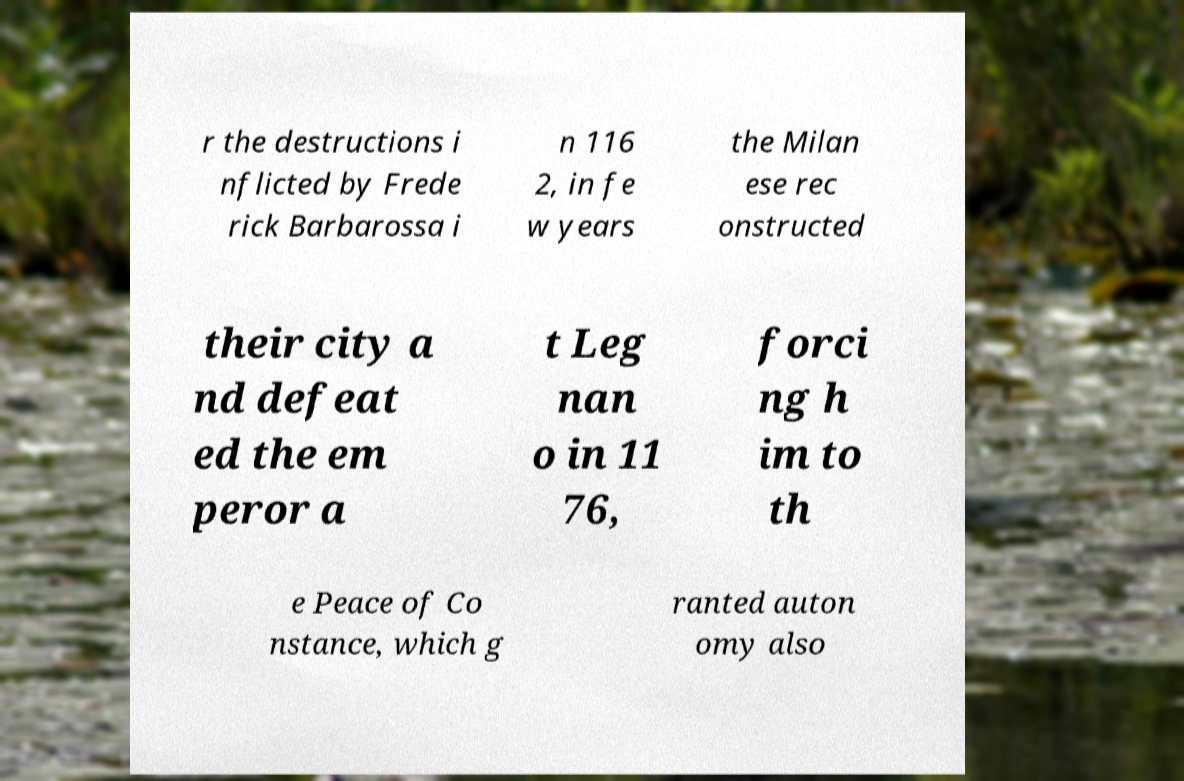Can you read and provide the text displayed in the image?This photo seems to have some interesting text. Can you extract and type it out for me? r the destructions i nflicted by Frede rick Barbarossa i n 116 2, in fe w years the Milan ese rec onstructed their city a nd defeat ed the em peror a t Leg nan o in 11 76, forci ng h im to th e Peace of Co nstance, which g ranted auton omy also 